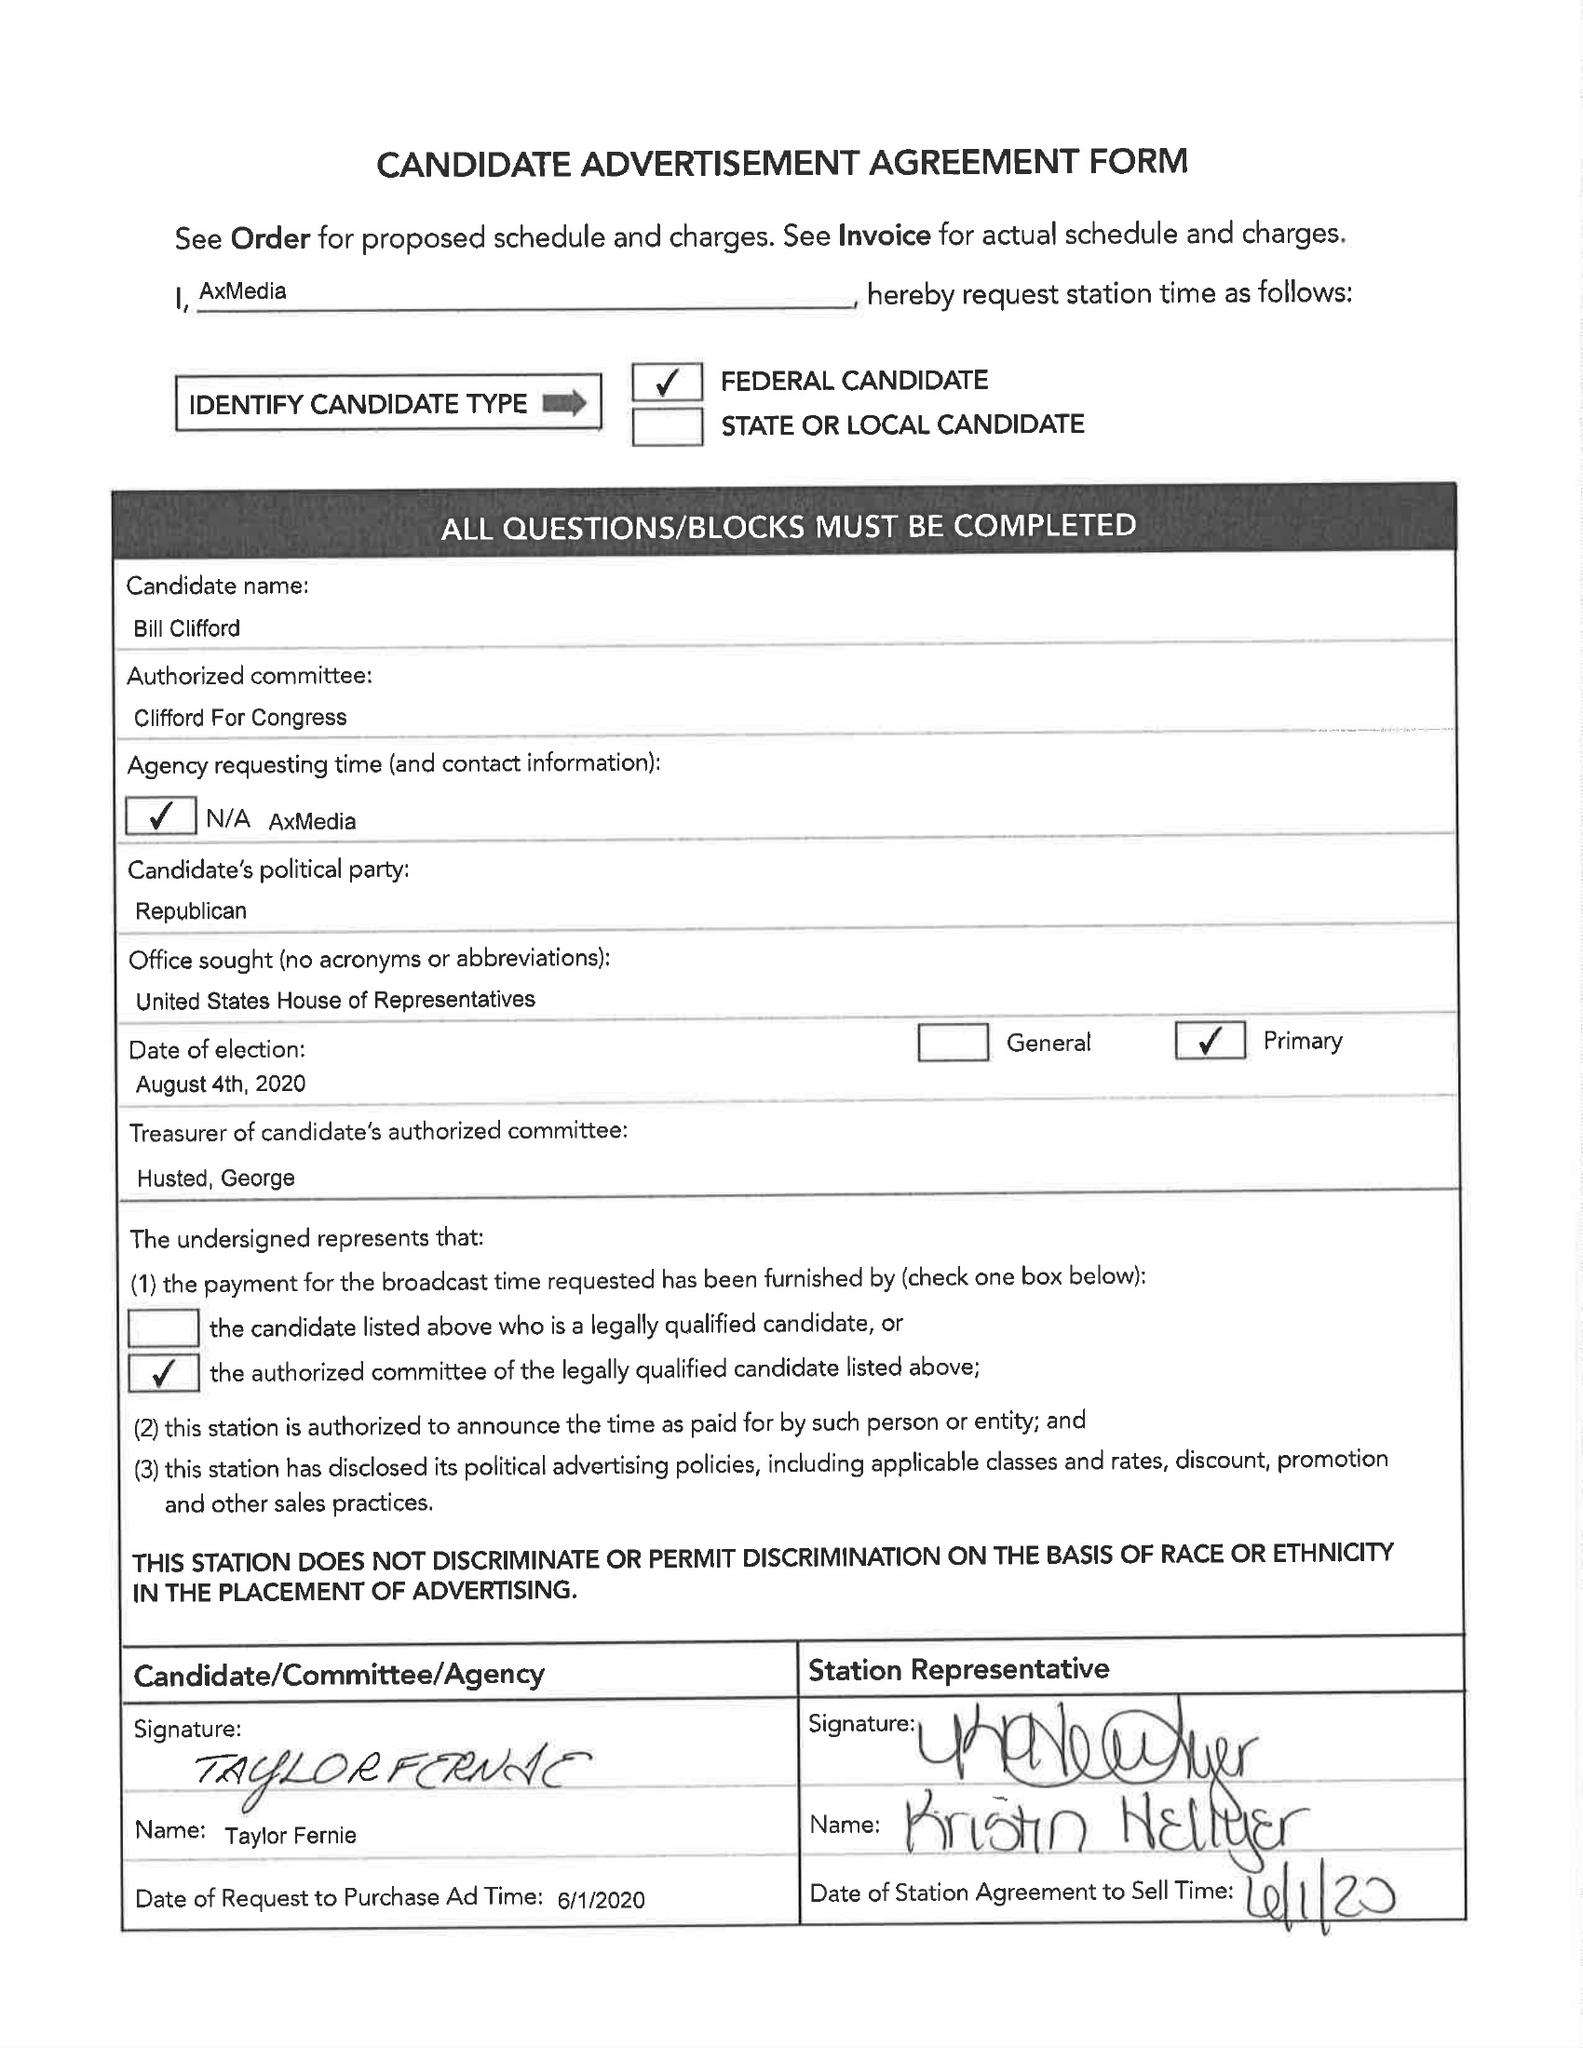What is the value for the flight_to?
Answer the question using a single word or phrase. 06/08/20 